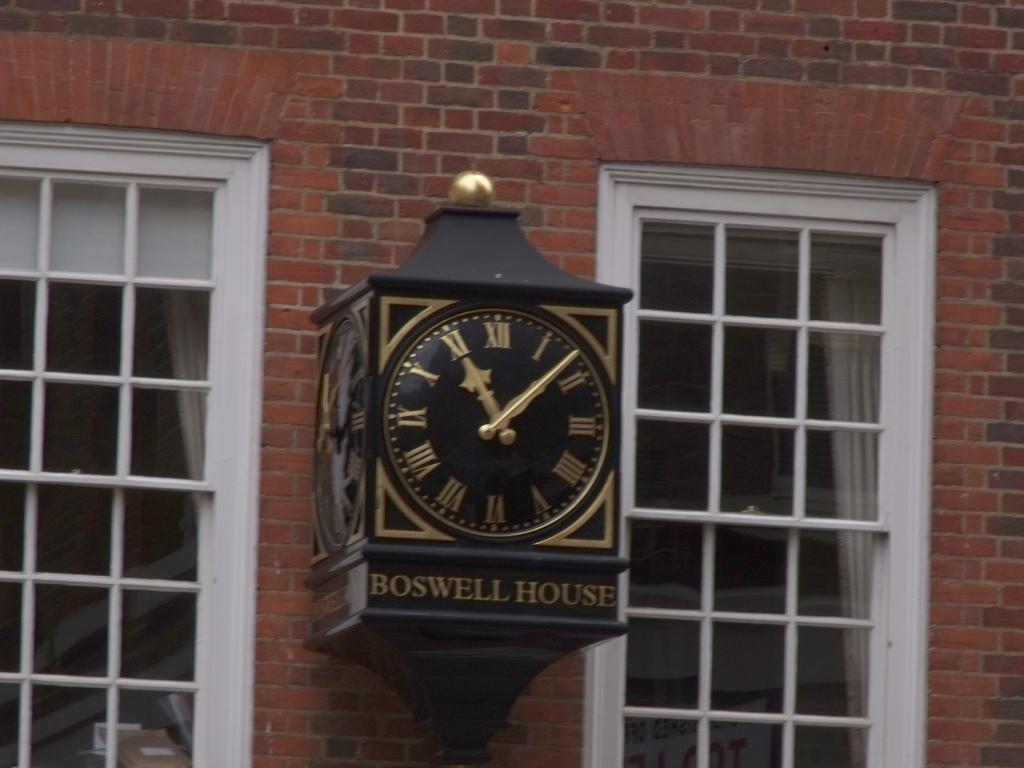What is the name of the house?
Your answer should be very brief. Boswell. Is the public clock or not?
Your response must be concise. Yes. 